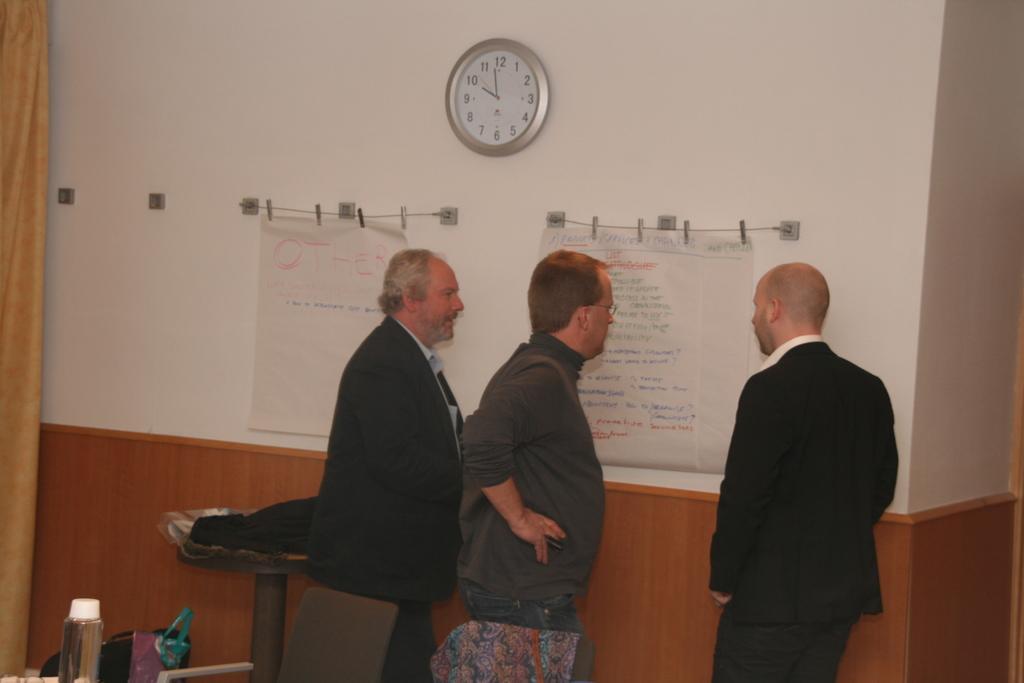Could you give a brief overview of what you see in this image? In this image we can see three people standing in a room, in front them there is are posters hanged to the wall and there is a wall clock, beside the person there is a table and an object on the table, there is a bottle and a chair behind the person. 